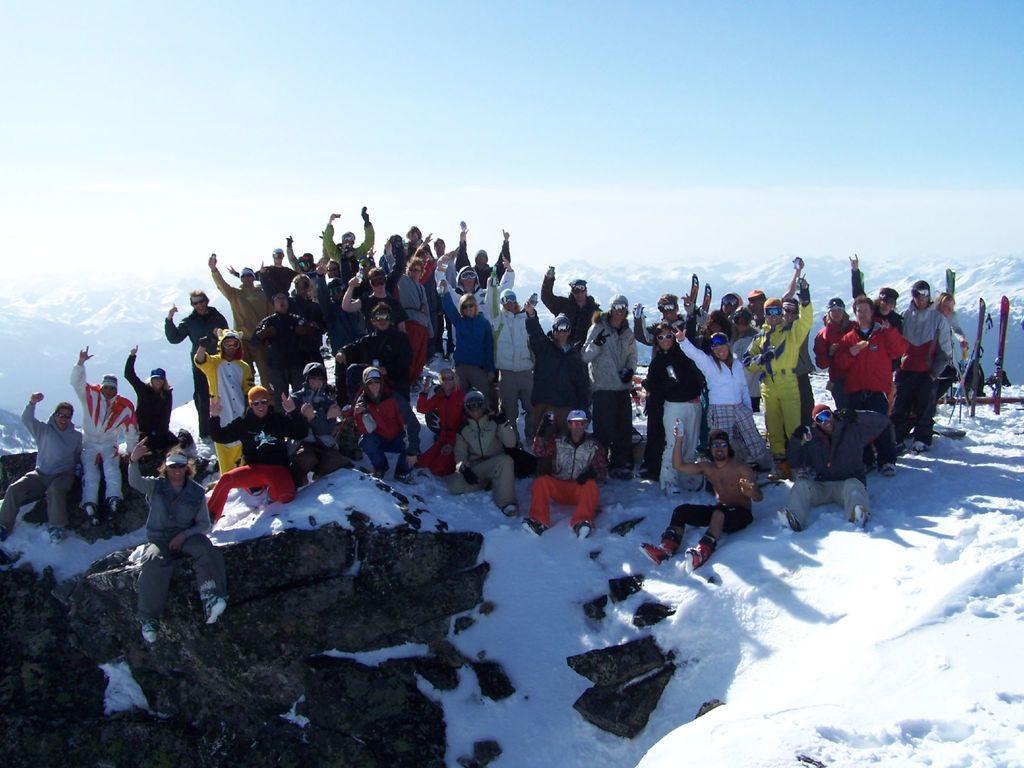How would you summarize this image in a sentence or two? In this picture there are group of people standing and there are group of people sitting. At the back there are mountains. At the top there is sky and there are clouds. At the bottom there is snow and there are rocks. 